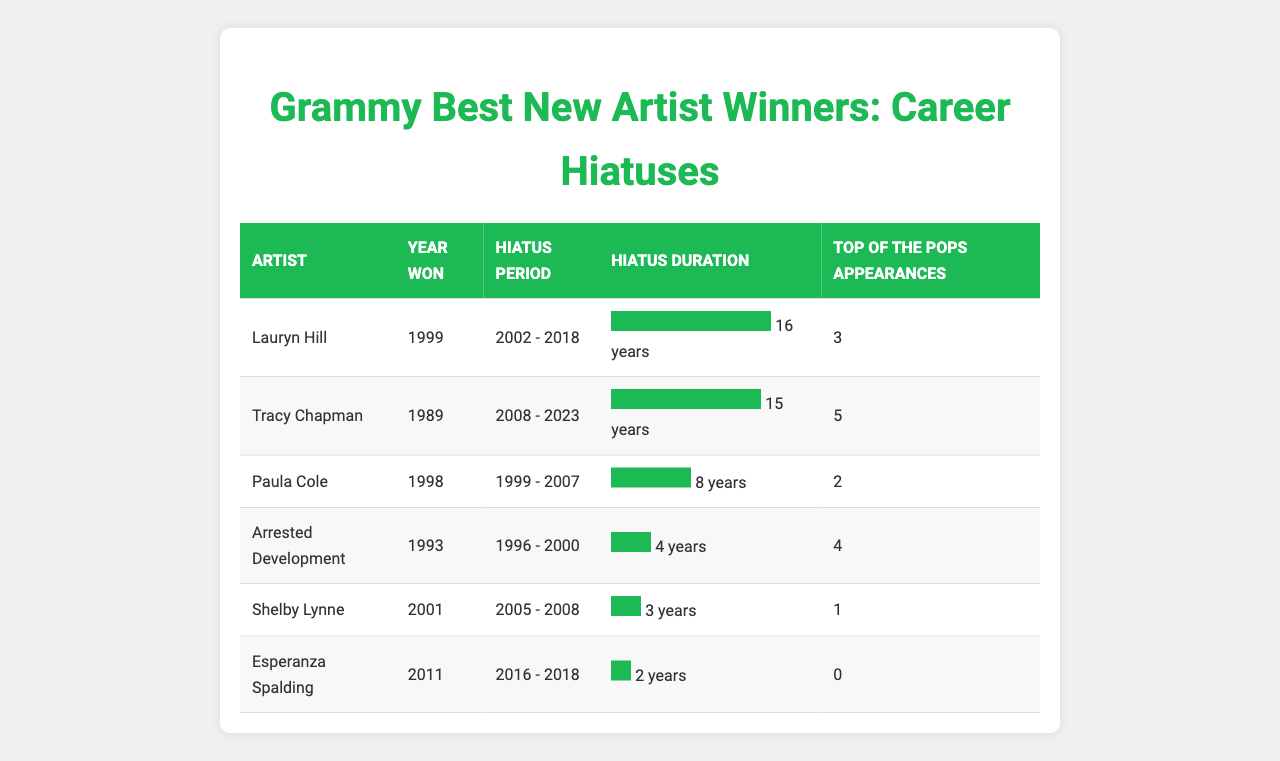What year did Lauryn Hill win the Grammy Award for Best New Artist? According to the table, Lauryn Hill won the Grammy Award in the year 1999.
Answer: 1999 How long was Tracy Chapman on hiatus? The table shows that Tracy Chapman had a hiatus duration of 15 years, starting from 2008 and ending in 2023.
Answer: 15 years Which artist had the shortest hiatus duration? By comparing the hiatus durations in the table, we see that Esperanza Spalding had the shortest hiatus of 2 years.
Answer: Esperanza Spalding Did Paula Cole have more Top of the Pops appearances than Shelby Lynne? The table indicates that Paula Cole had 2 appearances while Shelby Lynne had only 1. Therefore, Paula Cole did have more appearances.
Answer: Yes What is the average hiatus duration of the artists listed in the table? Adding the hiatus durations: 16 + 15 + 8 + 4 + 3 + 2 = 48 years. There are 6 artists, so average = 48 / 6 = 8 years.
Answer: 8 years How many artists had a hiatus that lasted more than 10 years? By examining the table, Lauryn Hill (16 years) and Tracy Chapman (15 years) had hiatus durations of more than 10 years. Therefore, there are 2 artists.
Answer: 2 Which artist had the most Top of The Pops appearances? The table indicates that Tracy Chapman had the most appearances at 5, compared to others.
Answer: Tracy Chapman What was the cumulative hiatus duration of Lauryn Hill and Paula Cole? The hiatus of Lauryn Hill is 16 years and Paula Cole's is 8 years. Summing these gives 16 + 8 = 24 years.
Answer: 24 years Is it true that all listed artists had a hiatus in their careers? Yes, according to the table, all the artists had initialized hiatuses at some point in their careers.
Answer: Yes Which artist's hiatus lasted from 2005 to 2008? The table shows that Shelby Lynne had a hiatus that started in 2005 and ended in 2008.
Answer: Shelby Lynne 